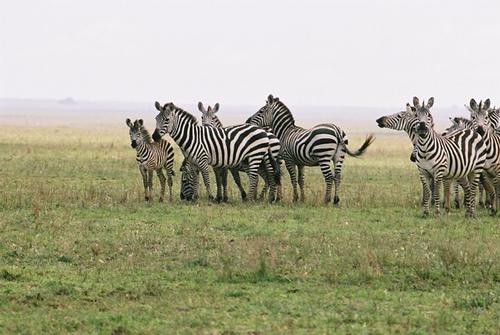How many zebras are there?
Answer briefly. 8. How many vehicles are there?
Give a very brief answer. 0. Are the animals running?
Be succinct. No. What color is the grass?
Give a very brief answer. Green. Are the zebras grazing?
Concise answer only. No. Are these zebra's nervous about a predator?
Concise answer only. No. 